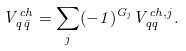<formula> <loc_0><loc_0><loc_500><loc_500>V _ { q \bar { q } } ^ { c h } = \sum _ { j } ( - 1 ) ^ { G _ { j } } V _ { q q } ^ { c h , j } .</formula> 